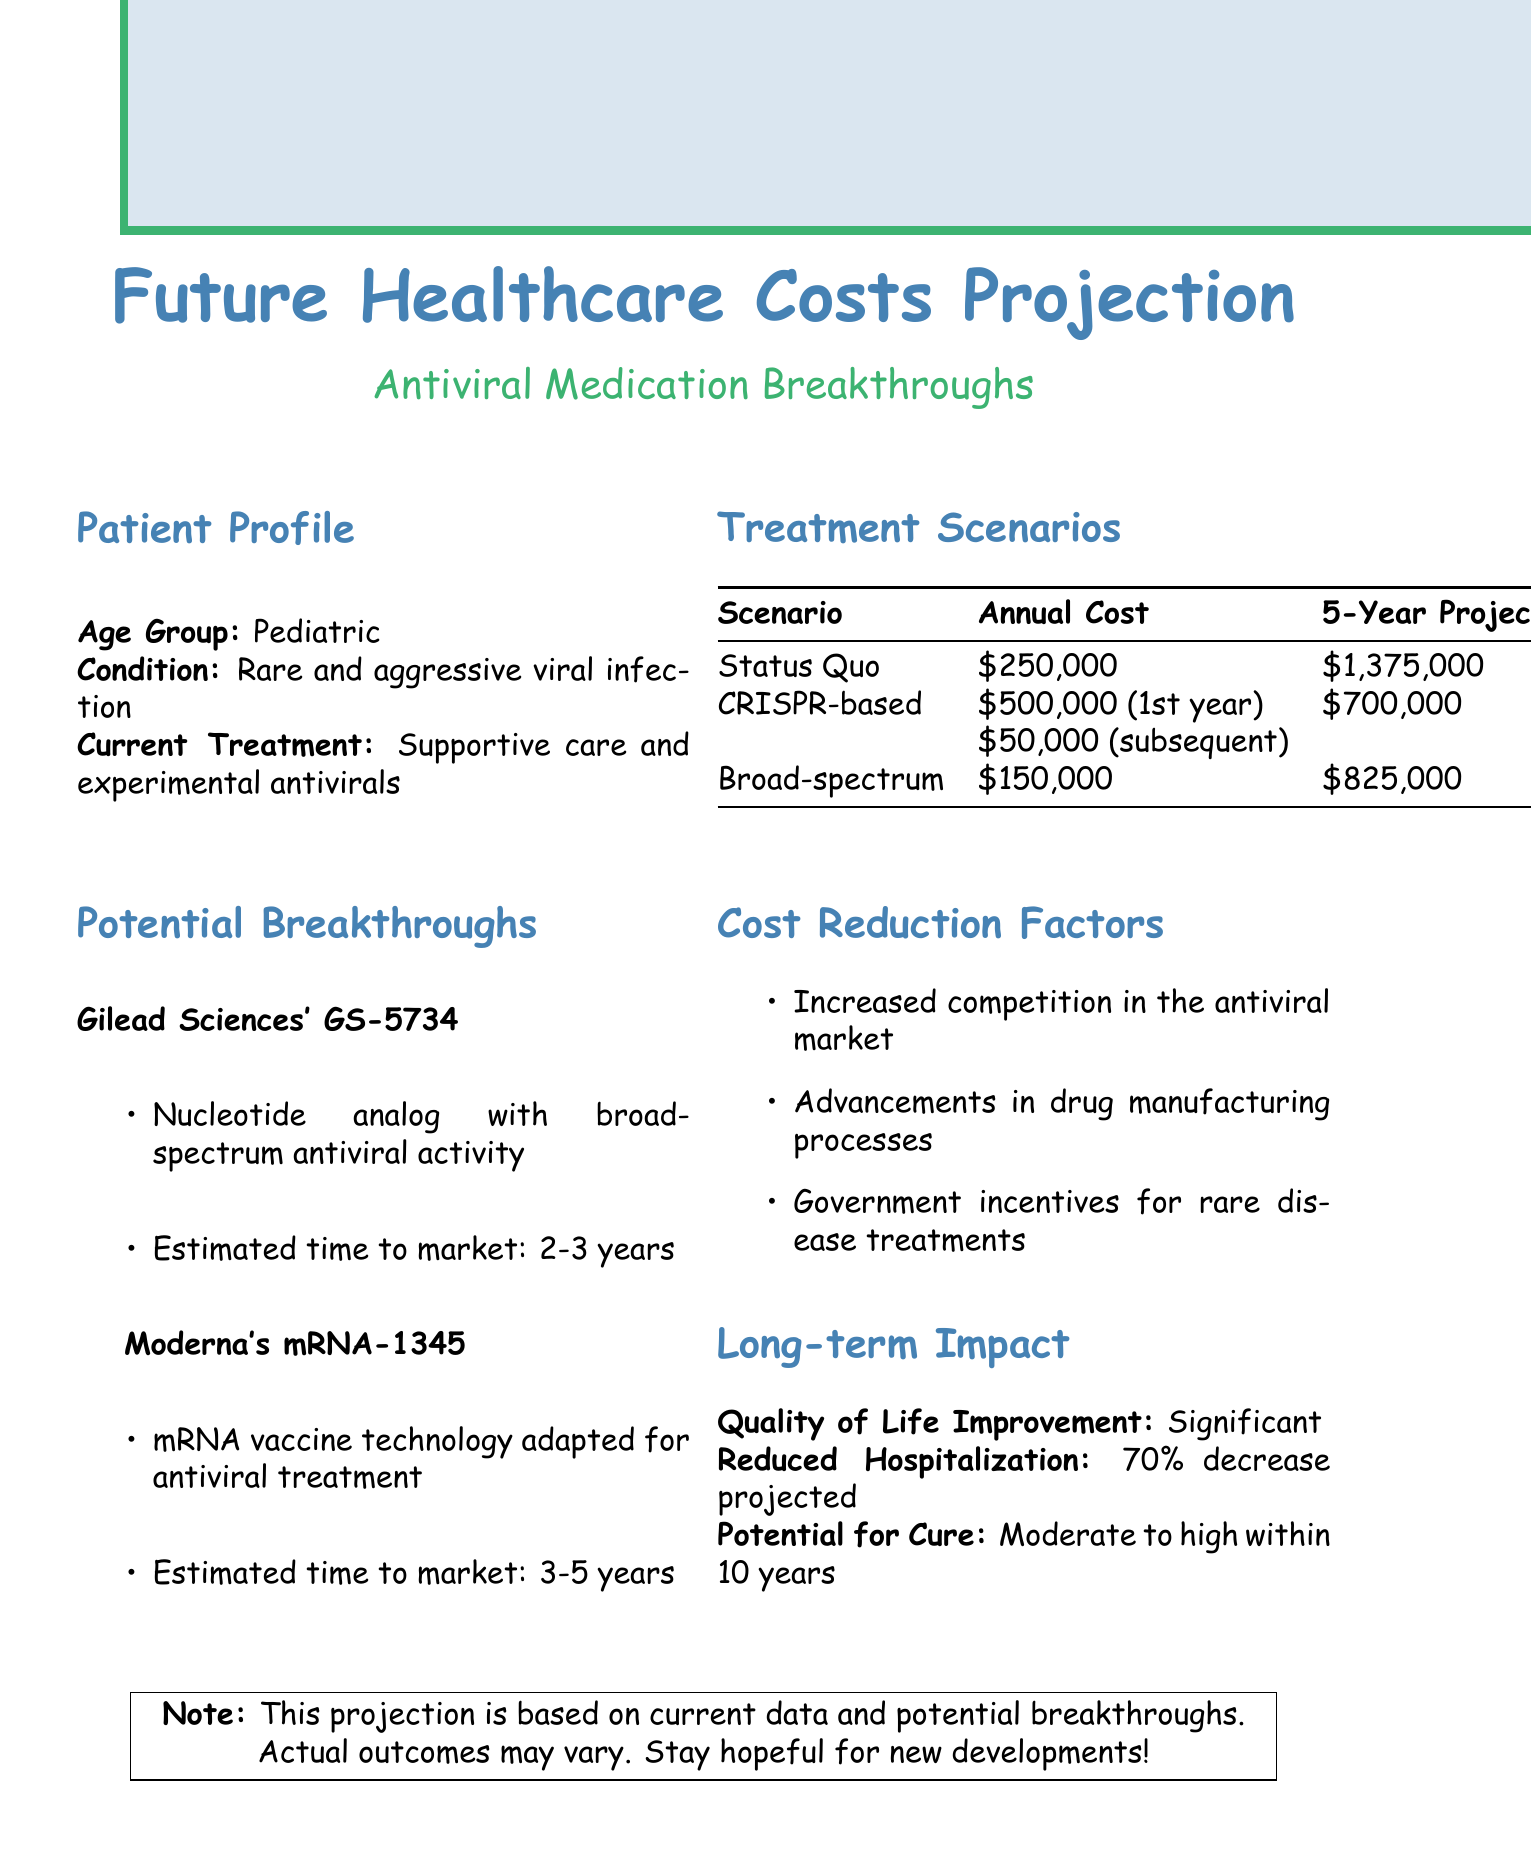What is the age group of the patient? The age group is indicated in the patient profile section, where it specifies "Pediatric."
Answer: Pediatric What is the total projected cost for the "Status Quo" treatment scenario over five years? The five-year cost projection for the "Status Quo" scenario is given as "$1,375,000."
Answer: $1,375,000 What is the estimated time to market for Gilead Sciences' GS-5734? The estimated time to market is stated clearly as "2-3 years."
Answer: 2-3 years What is the projected annual cost for the Broad-spectrum Antiviral treatment? The projected annual cost is listed as "$150,000."
Answer: $150,000 How much is the projected reduction in hospitalization? The document states "70% decrease projected" for reduced hospitalization.
Answer: 70% What factors could contribute to cost reductions in antiviral treatments? The document lists several factors, which include "Increased competition in the antiviral market."
Answer: Increased competition in the antiviral market Which breakthrough treatment is associated with gene-editing therapy? The breakthrough associated with gene-editing therapy is "CRISPR-based Antiviral."
Answer: CRISPR-based Antiviral What is the potential improvement in quality of life expected from these treatments? The document mentions a "Significant" quality of life improvement.
Answer: Significant What section provides information on current treatments for the patient profile? The section titled "Patient Profile" includes information about current treatments.
Answer: Patient Profile 